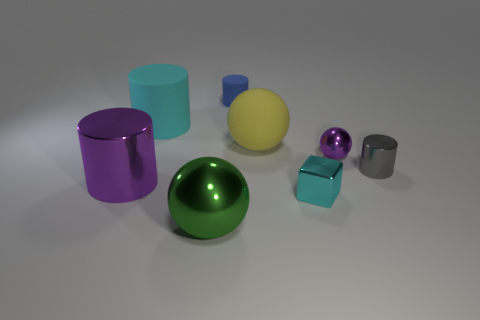Subtract all purple balls. How many balls are left? 2 Add 1 tiny gray things. How many objects exist? 9 Subtract 1 cylinders. How many cylinders are left? 3 Subtract all purple cylinders. How many cylinders are left? 3 Subtract all blocks. How many objects are left? 7 Subtract all yellow things. Subtract all tiny cyan things. How many objects are left? 6 Add 1 cyan cubes. How many cyan cubes are left? 2 Add 5 tiny blue cylinders. How many tiny blue cylinders exist? 6 Subtract 1 purple cylinders. How many objects are left? 7 Subtract all yellow spheres. Subtract all cyan cubes. How many spheres are left? 2 